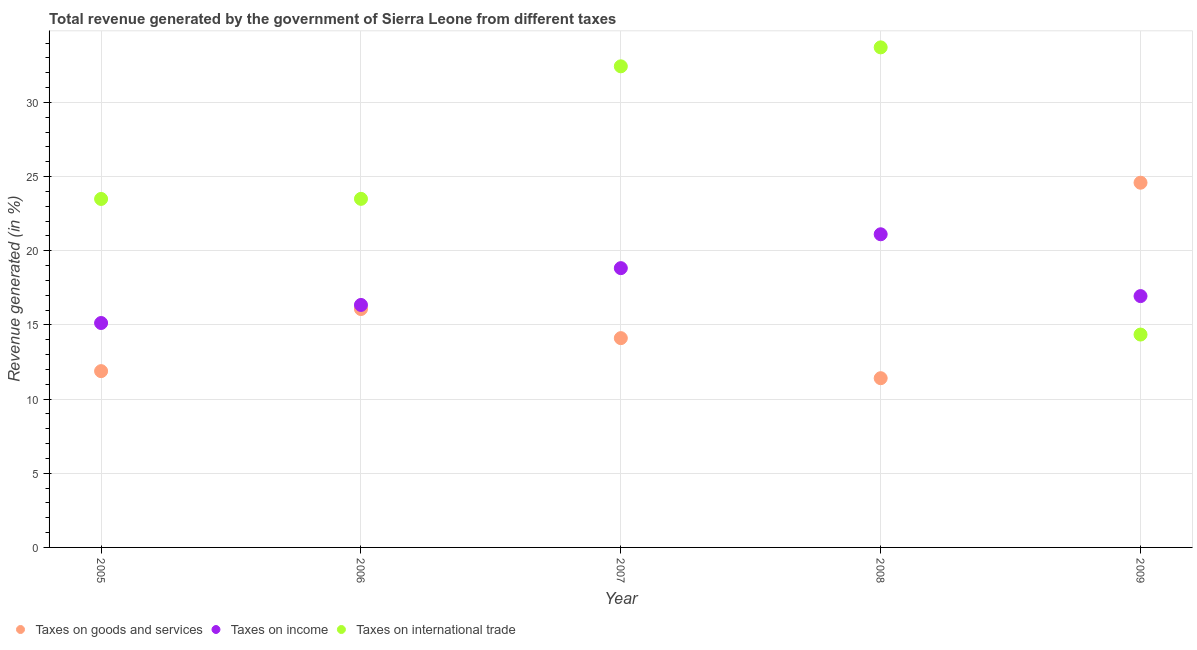How many different coloured dotlines are there?
Make the answer very short. 3. Is the number of dotlines equal to the number of legend labels?
Offer a very short reply. Yes. What is the percentage of revenue generated by taxes on goods and services in 2007?
Offer a terse response. 14.11. Across all years, what is the maximum percentage of revenue generated by taxes on goods and services?
Make the answer very short. 24.59. Across all years, what is the minimum percentage of revenue generated by tax on international trade?
Offer a terse response. 14.35. In which year was the percentage of revenue generated by taxes on income maximum?
Provide a succinct answer. 2008. In which year was the percentage of revenue generated by tax on international trade minimum?
Your answer should be very brief. 2009. What is the total percentage of revenue generated by taxes on goods and services in the graph?
Keep it short and to the point. 78.07. What is the difference between the percentage of revenue generated by taxes on goods and services in 2006 and that in 2009?
Ensure brevity in your answer.  -8.52. What is the difference between the percentage of revenue generated by tax on international trade in 2007 and the percentage of revenue generated by taxes on income in 2006?
Make the answer very short. 16.09. What is the average percentage of revenue generated by taxes on income per year?
Your answer should be compact. 17.67. In the year 2006, what is the difference between the percentage of revenue generated by tax on international trade and percentage of revenue generated by taxes on goods and services?
Your answer should be very brief. 7.43. What is the ratio of the percentage of revenue generated by tax on international trade in 2005 to that in 2006?
Make the answer very short. 1. Is the percentage of revenue generated by taxes on income in 2006 less than that in 2008?
Keep it short and to the point. Yes. Is the difference between the percentage of revenue generated by tax on international trade in 2006 and 2008 greater than the difference between the percentage of revenue generated by taxes on income in 2006 and 2008?
Provide a succinct answer. No. What is the difference between the highest and the second highest percentage of revenue generated by tax on international trade?
Your response must be concise. 1.28. What is the difference between the highest and the lowest percentage of revenue generated by tax on international trade?
Your answer should be compact. 19.36. Is it the case that in every year, the sum of the percentage of revenue generated by taxes on goods and services and percentage of revenue generated by taxes on income is greater than the percentage of revenue generated by tax on international trade?
Make the answer very short. No. How many dotlines are there?
Ensure brevity in your answer.  3. How many years are there in the graph?
Provide a short and direct response. 5. Are the values on the major ticks of Y-axis written in scientific E-notation?
Your answer should be very brief. No. Does the graph contain grids?
Offer a very short reply. Yes. How are the legend labels stacked?
Give a very brief answer. Horizontal. What is the title of the graph?
Offer a very short reply. Total revenue generated by the government of Sierra Leone from different taxes. Does "Tertiary" appear as one of the legend labels in the graph?
Your response must be concise. No. What is the label or title of the Y-axis?
Keep it short and to the point. Revenue generated (in %). What is the Revenue generated (in %) in Taxes on goods and services in 2005?
Provide a succinct answer. 11.89. What is the Revenue generated (in %) of Taxes on income in 2005?
Provide a succinct answer. 15.13. What is the Revenue generated (in %) in Taxes on international trade in 2005?
Provide a short and direct response. 23.5. What is the Revenue generated (in %) of Taxes on goods and services in 2006?
Your answer should be very brief. 16.07. What is the Revenue generated (in %) in Taxes on income in 2006?
Offer a very short reply. 16.35. What is the Revenue generated (in %) in Taxes on international trade in 2006?
Provide a succinct answer. 23.5. What is the Revenue generated (in %) in Taxes on goods and services in 2007?
Provide a short and direct response. 14.11. What is the Revenue generated (in %) of Taxes on income in 2007?
Your response must be concise. 18.83. What is the Revenue generated (in %) in Taxes on international trade in 2007?
Your answer should be very brief. 32.44. What is the Revenue generated (in %) in Taxes on goods and services in 2008?
Provide a short and direct response. 11.41. What is the Revenue generated (in %) in Taxes on income in 2008?
Your answer should be compact. 21.11. What is the Revenue generated (in %) in Taxes on international trade in 2008?
Offer a terse response. 33.72. What is the Revenue generated (in %) of Taxes on goods and services in 2009?
Your answer should be very brief. 24.59. What is the Revenue generated (in %) of Taxes on income in 2009?
Provide a succinct answer. 16.95. What is the Revenue generated (in %) in Taxes on international trade in 2009?
Provide a short and direct response. 14.35. Across all years, what is the maximum Revenue generated (in %) of Taxes on goods and services?
Your answer should be very brief. 24.59. Across all years, what is the maximum Revenue generated (in %) of Taxes on income?
Your answer should be very brief. 21.11. Across all years, what is the maximum Revenue generated (in %) in Taxes on international trade?
Provide a short and direct response. 33.72. Across all years, what is the minimum Revenue generated (in %) in Taxes on goods and services?
Keep it short and to the point. 11.41. Across all years, what is the minimum Revenue generated (in %) in Taxes on income?
Make the answer very short. 15.13. Across all years, what is the minimum Revenue generated (in %) of Taxes on international trade?
Provide a succinct answer. 14.35. What is the total Revenue generated (in %) in Taxes on goods and services in the graph?
Offer a terse response. 78.07. What is the total Revenue generated (in %) in Taxes on income in the graph?
Ensure brevity in your answer.  88.37. What is the total Revenue generated (in %) in Taxes on international trade in the graph?
Make the answer very short. 127.51. What is the difference between the Revenue generated (in %) in Taxes on goods and services in 2005 and that in 2006?
Your response must be concise. -4.19. What is the difference between the Revenue generated (in %) in Taxes on income in 2005 and that in 2006?
Give a very brief answer. -1.22. What is the difference between the Revenue generated (in %) of Taxes on international trade in 2005 and that in 2006?
Offer a very short reply. -0.01. What is the difference between the Revenue generated (in %) of Taxes on goods and services in 2005 and that in 2007?
Your answer should be compact. -2.23. What is the difference between the Revenue generated (in %) in Taxes on income in 2005 and that in 2007?
Keep it short and to the point. -3.7. What is the difference between the Revenue generated (in %) of Taxes on international trade in 2005 and that in 2007?
Offer a terse response. -8.94. What is the difference between the Revenue generated (in %) of Taxes on goods and services in 2005 and that in 2008?
Make the answer very short. 0.48. What is the difference between the Revenue generated (in %) of Taxes on income in 2005 and that in 2008?
Keep it short and to the point. -5.98. What is the difference between the Revenue generated (in %) of Taxes on international trade in 2005 and that in 2008?
Ensure brevity in your answer.  -10.22. What is the difference between the Revenue generated (in %) of Taxes on goods and services in 2005 and that in 2009?
Provide a succinct answer. -12.7. What is the difference between the Revenue generated (in %) of Taxes on income in 2005 and that in 2009?
Provide a succinct answer. -1.81. What is the difference between the Revenue generated (in %) of Taxes on international trade in 2005 and that in 2009?
Provide a succinct answer. 9.14. What is the difference between the Revenue generated (in %) of Taxes on goods and services in 2006 and that in 2007?
Make the answer very short. 1.96. What is the difference between the Revenue generated (in %) of Taxes on income in 2006 and that in 2007?
Ensure brevity in your answer.  -2.48. What is the difference between the Revenue generated (in %) of Taxes on international trade in 2006 and that in 2007?
Ensure brevity in your answer.  -8.94. What is the difference between the Revenue generated (in %) in Taxes on goods and services in 2006 and that in 2008?
Provide a succinct answer. 4.66. What is the difference between the Revenue generated (in %) in Taxes on income in 2006 and that in 2008?
Ensure brevity in your answer.  -4.77. What is the difference between the Revenue generated (in %) in Taxes on international trade in 2006 and that in 2008?
Offer a terse response. -10.21. What is the difference between the Revenue generated (in %) in Taxes on goods and services in 2006 and that in 2009?
Keep it short and to the point. -8.52. What is the difference between the Revenue generated (in %) in Taxes on income in 2006 and that in 2009?
Keep it short and to the point. -0.6. What is the difference between the Revenue generated (in %) of Taxes on international trade in 2006 and that in 2009?
Your response must be concise. 9.15. What is the difference between the Revenue generated (in %) in Taxes on goods and services in 2007 and that in 2008?
Make the answer very short. 2.7. What is the difference between the Revenue generated (in %) of Taxes on income in 2007 and that in 2008?
Your answer should be very brief. -2.28. What is the difference between the Revenue generated (in %) of Taxes on international trade in 2007 and that in 2008?
Your answer should be compact. -1.28. What is the difference between the Revenue generated (in %) of Taxes on goods and services in 2007 and that in 2009?
Give a very brief answer. -10.48. What is the difference between the Revenue generated (in %) of Taxes on income in 2007 and that in 2009?
Keep it short and to the point. 1.88. What is the difference between the Revenue generated (in %) in Taxes on international trade in 2007 and that in 2009?
Your answer should be compact. 18.09. What is the difference between the Revenue generated (in %) in Taxes on goods and services in 2008 and that in 2009?
Provide a succinct answer. -13.18. What is the difference between the Revenue generated (in %) in Taxes on income in 2008 and that in 2009?
Your response must be concise. 4.17. What is the difference between the Revenue generated (in %) of Taxes on international trade in 2008 and that in 2009?
Your response must be concise. 19.36. What is the difference between the Revenue generated (in %) of Taxes on goods and services in 2005 and the Revenue generated (in %) of Taxes on income in 2006?
Give a very brief answer. -4.46. What is the difference between the Revenue generated (in %) of Taxes on goods and services in 2005 and the Revenue generated (in %) of Taxes on international trade in 2006?
Make the answer very short. -11.62. What is the difference between the Revenue generated (in %) of Taxes on income in 2005 and the Revenue generated (in %) of Taxes on international trade in 2006?
Ensure brevity in your answer.  -8.37. What is the difference between the Revenue generated (in %) of Taxes on goods and services in 2005 and the Revenue generated (in %) of Taxes on income in 2007?
Provide a succinct answer. -6.94. What is the difference between the Revenue generated (in %) in Taxes on goods and services in 2005 and the Revenue generated (in %) in Taxes on international trade in 2007?
Offer a terse response. -20.55. What is the difference between the Revenue generated (in %) of Taxes on income in 2005 and the Revenue generated (in %) of Taxes on international trade in 2007?
Ensure brevity in your answer.  -17.31. What is the difference between the Revenue generated (in %) in Taxes on goods and services in 2005 and the Revenue generated (in %) in Taxes on income in 2008?
Your response must be concise. -9.23. What is the difference between the Revenue generated (in %) in Taxes on goods and services in 2005 and the Revenue generated (in %) in Taxes on international trade in 2008?
Give a very brief answer. -21.83. What is the difference between the Revenue generated (in %) of Taxes on income in 2005 and the Revenue generated (in %) of Taxes on international trade in 2008?
Offer a terse response. -18.59. What is the difference between the Revenue generated (in %) in Taxes on goods and services in 2005 and the Revenue generated (in %) in Taxes on income in 2009?
Offer a very short reply. -5.06. What is the difference between the Revenue generated (in %) of Taxes on goods and services in 2005 and the Revenue generated (in %) of Taxes on international trade in 2009?
Your answer should be very brief. -2.47. What is the difference between the Revenue generated (in %) of Taxes on income in 2005 and the Revenue generated (in %) of Taxes on international trade in 2009?
Your answer should be very brief. 0.78. What is the difference between the Revenue generated (in %) in Taxes on goods and services in 2006 and the Revenue generated (in %) in Taxes on income in 2007?
Provide a succinct answer. -2.76. What is the difference between the Revenue generated (in %) in Taxes on goods and services in 2006 and the Revenue generated (in %) in Taxes on international trade in 2007?
Keep it short and to the point. -16.36. What is the difference between the Revenue generated (in %) in Taxes on income in 2006 and the Revenue generated (in %) in Taxes on international trade in 2007?
Your answer should be very brief. -16.09. What is the difference between the Revenue generated (in %) of Taxes on goods and services in 2006 and the Revenue generated (in %) of Taxes on income in 2008?
Offer a very short reply. -5.04. What is the difference between the Revenue generated (in %) in Taxes on goods and services in 2006 and the Revenue generated (in %) in Taxes on international trade in 2008?
Offer a terse response. -17.64. What is the difference between the Revenue generated (in %) in Taxes on income in 2006 and the Revenue generated (in %) in Taxes on international trade in 2008?
Your response must be concise. -17.37. What is the difference between the Revenue generated (in %) in Taxes on goods and services in 2006 and the Revenue generated (in %) in Taxes on income in 2009?
Offer a very short reply. -0.87. What is the difference between the Revenue generated (in %) of Taxes on goods and services in 2006 and the Revenue generated (in %) of Taxes on international trade in 2009?
Make the answer very short. 1.72. What is the difference between the Revenue generated (in %) in Taxes on income in 2006 and the Revenue generated (in %) in Taxes on international trade in 2009?
Your response must be concise. 2. What is the difference between the Revenue generated (in %) in Taxes on goods and services in 2007 and the Revenue generated (in %) in Taxes on income in 2008?
Keep it short and to the point. -7. What is the difference between the Revenue generated (in %) in Taxes on goods and services in 2007 and the Revenue generated (in %) in Taxes on international trade in 2008?
Ensure brevity in your answer.  -19.61. What is the difference between the Revenue generated (in %) of Taxes on income in 2007 and the Revenue generated (in %) of Taxes on international trade in 2008?
Offer a terse response. -14.89. What is the difference between the Revenue generated (in %) of Taxes on goods and services in 2007 and the Revenue generated (in %) of Taxes on income in 2009?
Your response must be concise. -2.83. What is the difference between the Revenue generated (in %) in Taxes on goods and services in 2007 and the Revenue generated (in %) in Taxes on international trade in 2009?
Ensure brevity in your answer.  -0.24. What is the difference between the Revenue generated (in %) of Taxes on income in 2007 and the Revenue generated (in %) of Taxes on international trade in 2009?
Your answer should be compact. 4.48. What is the difference between the Revenue generated (in %) in Taxes on goods and services in 2008 and the Revenue generated (in %) in Taxes on income in 2009?
Provide a succinct answer. -5.54. What is the difference between the Revenue generated (in %) in Taxes on goods and services in 2008 and the Revenue generated (in %) in Taxes on international trade in 2009?
Make the answer very short. -2.94. What is the difference between the Revenue generated (in %) of Taxes on income in 2008 and the Revenue generated (in %) of Taxes on international trade in 2009?
Keep it short and to the point. 6.76. What is the average Revenue generated (in %) in Taxes on goods and services per year?
Keep it short and to the point. 15.61. What is the average Revenue generated (in %) in Taxes on income per year?
Provide a succinct answer. 17.67. What is the average Revenue generated (in %) in Taxes on international trade per year?
Offer a terse response. 25.5. In the year 2005, what is the difference between the Revenue generated (in %) of Taxes on goods and services and Revenue generated (in %) of Taxes on income?
Your answer should be compact. -3.25. In the year 2005, what is the difference between the Revenue generated (in %) in Taxes on goods and services and Revenue generated (in %) in Taxes on international trade?
Provide a short and direct response. -11.61. In the year 2005, what is the difference between the Revenue generated (in %) of Taxes on income and Revenue generated (in %) of Taxes on international trade?
Give a very brief answer. -8.36. In the year 2006, what is the difference between the Revenue generated (in %) in Taxes on goods and services and Revenue generated (in %) in Taxes on income?
Your answer should be very brief. -0.27. In the year 2006, what is the difference between the Revenue generated (in %) of Taxes on goods and services and Revenue generated (in %) of Taxes on international trade?
Provide a succinct answer. -7.43. In the year 2006, what is the difference between the Revenue generated (in %) of Taxes on income and Revenue generated (in %) of Taxes on international trade?
Give a very brief answer. -7.15. In the year 2007, what is the difference between the Revenue generated (in %) in Taxes on goods and services and Revenue generated (in %) in Taxes on income?
Your answer should be compact. -4.72. In the year 2007, what is the difference between the Revenue generated (in %) of Taxes on goods and services and Revenue generated (in %) of Taxes on international trade?
Give a very brief answer. -18.33. In the year 2007, what is the difference between the Revenue generated (in %) in Taxes on income and Revenue generated (in %) in Taxes on international trade?
Provide a short and direct response. -13.61. In the year 2008, what is the difference between the Revenue generated (in %) of Taxes on goods and services and Revenue generated (in %) of Taxes on income?
Make the answer very short. -9.7. In the year 2008, what is the difference between the Revenue generated (in %) in Taxes on goods and services and Revenue generated (in %) in Taxes on international trade?
Offer a terse response. -22.31. In the year 2008, what is the difference between the Revenue generated (in %) of Taxes on income and Revenue generated (in %) of Taxes on international trade?
Make the answer very short. -12.6. In the year 2009, what is the difference between the Revenue generated (in %) in Taxes on goods and services and Revenue generated (in %) in Taxes on income?
Ensure brevity in your answer.  7.64. In the year 2009, what is the difference between the Revenue generated (in %) of Taxes on goods and services and Revenue generated (in %) of Taxes on international trade?
Ensure brevity in your answer.  10.24. In the year 2009, what is the difference between the Revenue generated (in %) in Taxes on income and Revenue generated (in %) in Taxes on international trade?
Offer a terse response. 2.59. What is the ratio of the Revenue generated (in %) of Taxes on goods and services in 2005 to that in 2006?
Make the answer very short. 0.74. What is the ratio of the Revenue generated (in %) in Taxes on income in 2005 to that in 2006?
Ensure brevity in your answer.  0.93. What is the ratio of the Revenue generated (in %) in Taxes on international trade in 2005 to that in 2006?
Give a very brief answer. 1. What is the ratio of the Revenue generated (in %) of Taxes on goods and services in 2005 to that in 2007?
Provide a succinct answer. 0.84. What is the ratio of the Revenue generated (in %) of Taxes on income in 2005 to that in 2007?
Make the answer very short. 0.8. What is the ratio of the Revenue generated (in %) in Taxes on international trade in 2005 to that in 2007?
Offer a very short reply. 0.72. What is the ratio of the Revenue generated (in %) of Taxes on goods and services in 2005 to that in 2008?
Give a very brief answer. 1.04. What is the ratio of the Revenue generated (in %) in Taxes on income in 2005 to that in 2008?
Offer a terse response. 0.72. What is the ratio of the Revenue generated (in %) of Taxes on international trade in 2005 to that in 2008?
Keep it short and to the point. 0.7. What is the ratio of the Revenue generated (in %) of Taxes on goods and services in 2005 to that in 2009?
Ensure brevity in your answer.  0.48. What is the ratio of the Revenue generated (in %) of Taxes on income in 2005 to that in 2009?
Offer a terse response. 0.89. What is the ratio of the Revenue generated (in %) in Taxes on international trade in 2005 to that in 2009?
Provide a succinct answer. 1.64. What is the ratio of the Revenue generated (in %) of Taxes on goods and services in 2006 to that in 2007?
Your answer should be compact. 1.14. What is the ratio of the Revenue generated (in %) of Taxes on income in 2006 to that in 2007?
Your answer should be compact. 0.87. What is the ratio of the Revenue generated (in %) in Taxes on international trade in 2006 to that in 2007?
Give a very brief answer. 0.72. What is the ratio of the Revenue generated (in %) in Taxes on goods and services in 2006 to that in 2008?
Your answer should be compact. 1.41. What is the ratio of the Revenue generated (in %) of Taxes on income in 2006 to that in 2008?
Your response must be concise. 0.77. What is the ratio of the Revenue generated (in %) of Taxes on international trade in 2006 to that in 2008?
Provide a short and direct response. 0.7. What is the ratio of the Revenue generated (in %) of Taxes on goods and services in 2006 to that in 2009?
Offer a terse response. 0.65. What is the ratio of the Revenue generated (in %) in Taxes on income in 2006 to that in 2009?
Make the answer very short. 0.96. What is the ratio of the Revenue generated (in %) in Taxes on international trade in 2006 to that in 2009?
Offer a terse response. 1.64. What is the ratio of the Revenue generated (in %) of Taxes on goods and services in 2007 to that in 2008?
Keep it short and to the point. 1.24. What is the ratio of the Revenue generated (in %) of Taxes on income in 2007 to that in 2008?
Offer a terse response. 0.89. What is the ratio of the Revenue generated (in %) in Taxes on international trade in 2007 to that in 2008?
Your answer should be compact. 0.96. What is the ratio of the Revenue generated (in %) in Taxes on goods and services in 2007 to that in 2009?
Offer a very short reply. 0.57. What is the ratio of the Revenue generated (in %) of Taxes on income in 2007 to that in 2009?
Provide a succinct answer. 1.11. What is the ratio of the Revenue generated (in %) of Taxes on international trade in 2007 to that in 2009?
Your response must be concise. 2.26. What is the ratio of the Revenue generated (in %) in Taxes on goods and services in 2008 to that in 2009?
Give a very brief answer. 0.46. What is the ratio of the Revenue generated (in %) in Taxes on income in 2008 to that in 2009?
Offer a terse response. 1.25. What is the ratio of the Revenue generated (in %) of Taxes on international trade in 2008 to that in 2009?
Your response must be concise. 2.35. What is the difference between the highest and the second highest Revenue generated (in %) in Taxes on goods and services?
Give a very brief answer. 8.52. What is the difference between the highest and the second highest Revenue generated (in %) of Taxes on income?
Provide a short and direct response. 2.28. What is the difference between the highest and the second highest Revenue generated (in %) of Taxes on international trade?
Offer a terse response. 1.28. What is the difference between the highest and the lowest Revenue generated (in %) in Taxes on goods and services?
Ensure brevity in your answer.  13.18. What is the difference between the highest and the lowest Revenue generated (in %) in Taxes on income?
Keep it short and to the point. 5.98. What is the difference between the highest and the lowest Revenue generated (in %) in Taxes on international trade?
Your answer should be very brief. 19.36. 